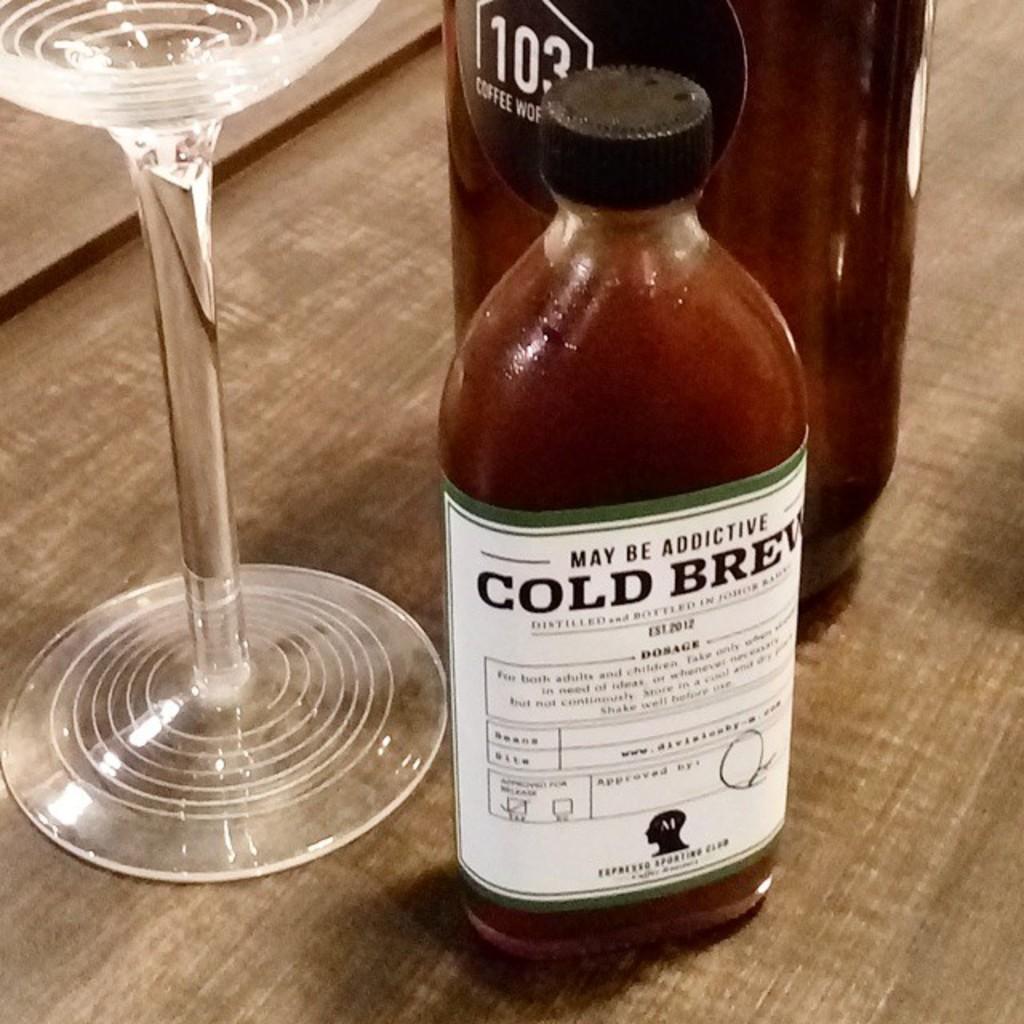Could you give a brief overview of what you see in this image? There is one glass and two bottles are kept on a wooden surface. 